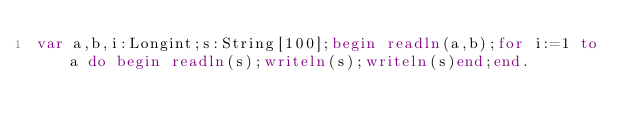<code> <loc_0><loc_0><loc_500><loc_500><_Pascal_>var a,b,i:Longint;s:String[100];begin readln(a,b);for i:=1 to a do begin readln(s);writeln(s);writeln(s)end;end.</code> 